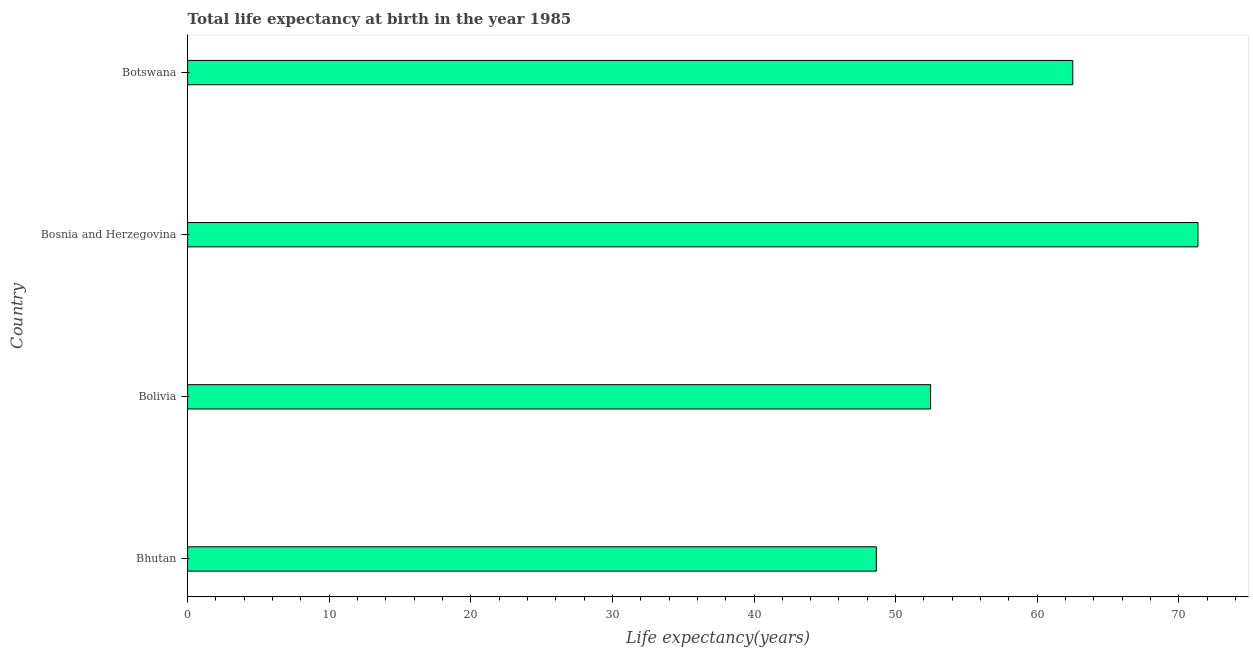Does the graph contain any zero values?
Ensure brevity in your answer.  No. What is the title of the graph?
Offer a very short reply. Total life expectancy at birth in the year 1985. What is the label or title of the X-axis?
Provide a short and direct response. Life expectancy(years). What is the label or title of the Y-axis?
Your response must be concise. Country. What is the life expectancy at birth in Bolivia?
Provide a succinct answer. 52.47. Across all countries, what is the maximum life expectancy at birth?
Offer a very short reply. 71.35. Across all countries, what is the minimum life expectancy at birth?
Your answer should be compact. 48.64. In which country was the life expectancy at birth maximum?
Ensure brevity in your answer.  Bosnia and Herzegovina. In which country was the life expectancy at birth minimum?
Make the answer very short. Bhutan. What is the sum of the life expectancy at birth?
Ensure brevity in your answer.  234.97. What is the difference between the life expectancy at birth in Bolivia and Botswana?
Ensure brevity in your answer.  -10.04. What is the average life expectancy at birth per country?
Provide a short and direct response. 58.74. What is the median life expectancy at birth?
Provide a short and direct response. 57.49. What is the ratio of the life expectancy at birth in Bhutan to that in Bolivia?
Keep it short and to the point. 0.93. Is the difference between the life expectancy at birth in Bhutan and Bolivia greater than the difference between any two countries?
Your answer should be compact. No. What is the difference between the highest and the second highest life expectancy at birth?
Ensure brevity in your answer.  8.84. Is the sum of the life expectancy at birth in Bolivia and Bosnia and Herzegovina greater than the maximum life expectancy at birth across all countries?
Keep it short and to the point. Yes. What is the difference between the highest and the lowest life expectancy at birth?
Ensure brevity in your answer.  22.71. How many countries are there in the graph?
Give a very brief answer. 4. What is the difference between two consecutive major ticks on the X-axis?
Your answer should be very brief. 10. What is the Life expectancy(years) in Bhutan?
Your answer should be very brief. 48.64. What is the Life expectancy(years) of Bolivia?
Give a very brief answer. 52.47. What is the Life expectancy(years) in Bosnia and Herzegovina?
Ensure brevity in your answer.  71.35. What is the Life expectancy(years) of Botswana?
Offer a terse response. 62.51. What is the difference between the Life expectancy(years) in Bhutan and Bolivia?
Give a very brief answer. -3.83. What is the difference between the Life expectancy(years) in Bhutan and Bosnia and Herzegovina?
Your answer should be very brief. -22.71. What is the difference between the Life expectancy(years) in Bhutan and Botswana?
Your answer should be very brief. -13.87. What is the difference between the Life expectancy(years) in Bolivia and Bosnia and Herzegovina?
Offer a very short reply. -18.88. What is the difference between the Life expectancy(years) in Bolivia and Botswana?
Your answer should be compact. -10.04. What is the difference between the Life expectancy(years) in Bosnia and Herzegovina and Botswana?
Give a very brief answer. 8.84. What is the ratio of the Life expectancy(years) in Bhutan to that in Bolivia?
Give a very brief answer. 0.93. What is the ratio of the Life expectancy(years) in Bhutan to that in Bosnia and Herzegovina?
Your answer should be very brief. 0.68. What is the ratio of the Life expectancy(years) in Bhutan to that in Botswana?
Ensure brevity in your answer.  0.78. What is the ratio of the Life expectancy(years) in Bolivia to that in Bosnia and Herzegovina?
Offer a very short reply. 0.73. What is the ratio of the Life expectancy(years) in Bolivia to that in Botswana?
Ensure brevity in your answer.  0.84. What is the ratio of the Life expectancy(years) in Bosnia and Herzegovina to that in Botswana?
Your response must be concise. 1.14. 